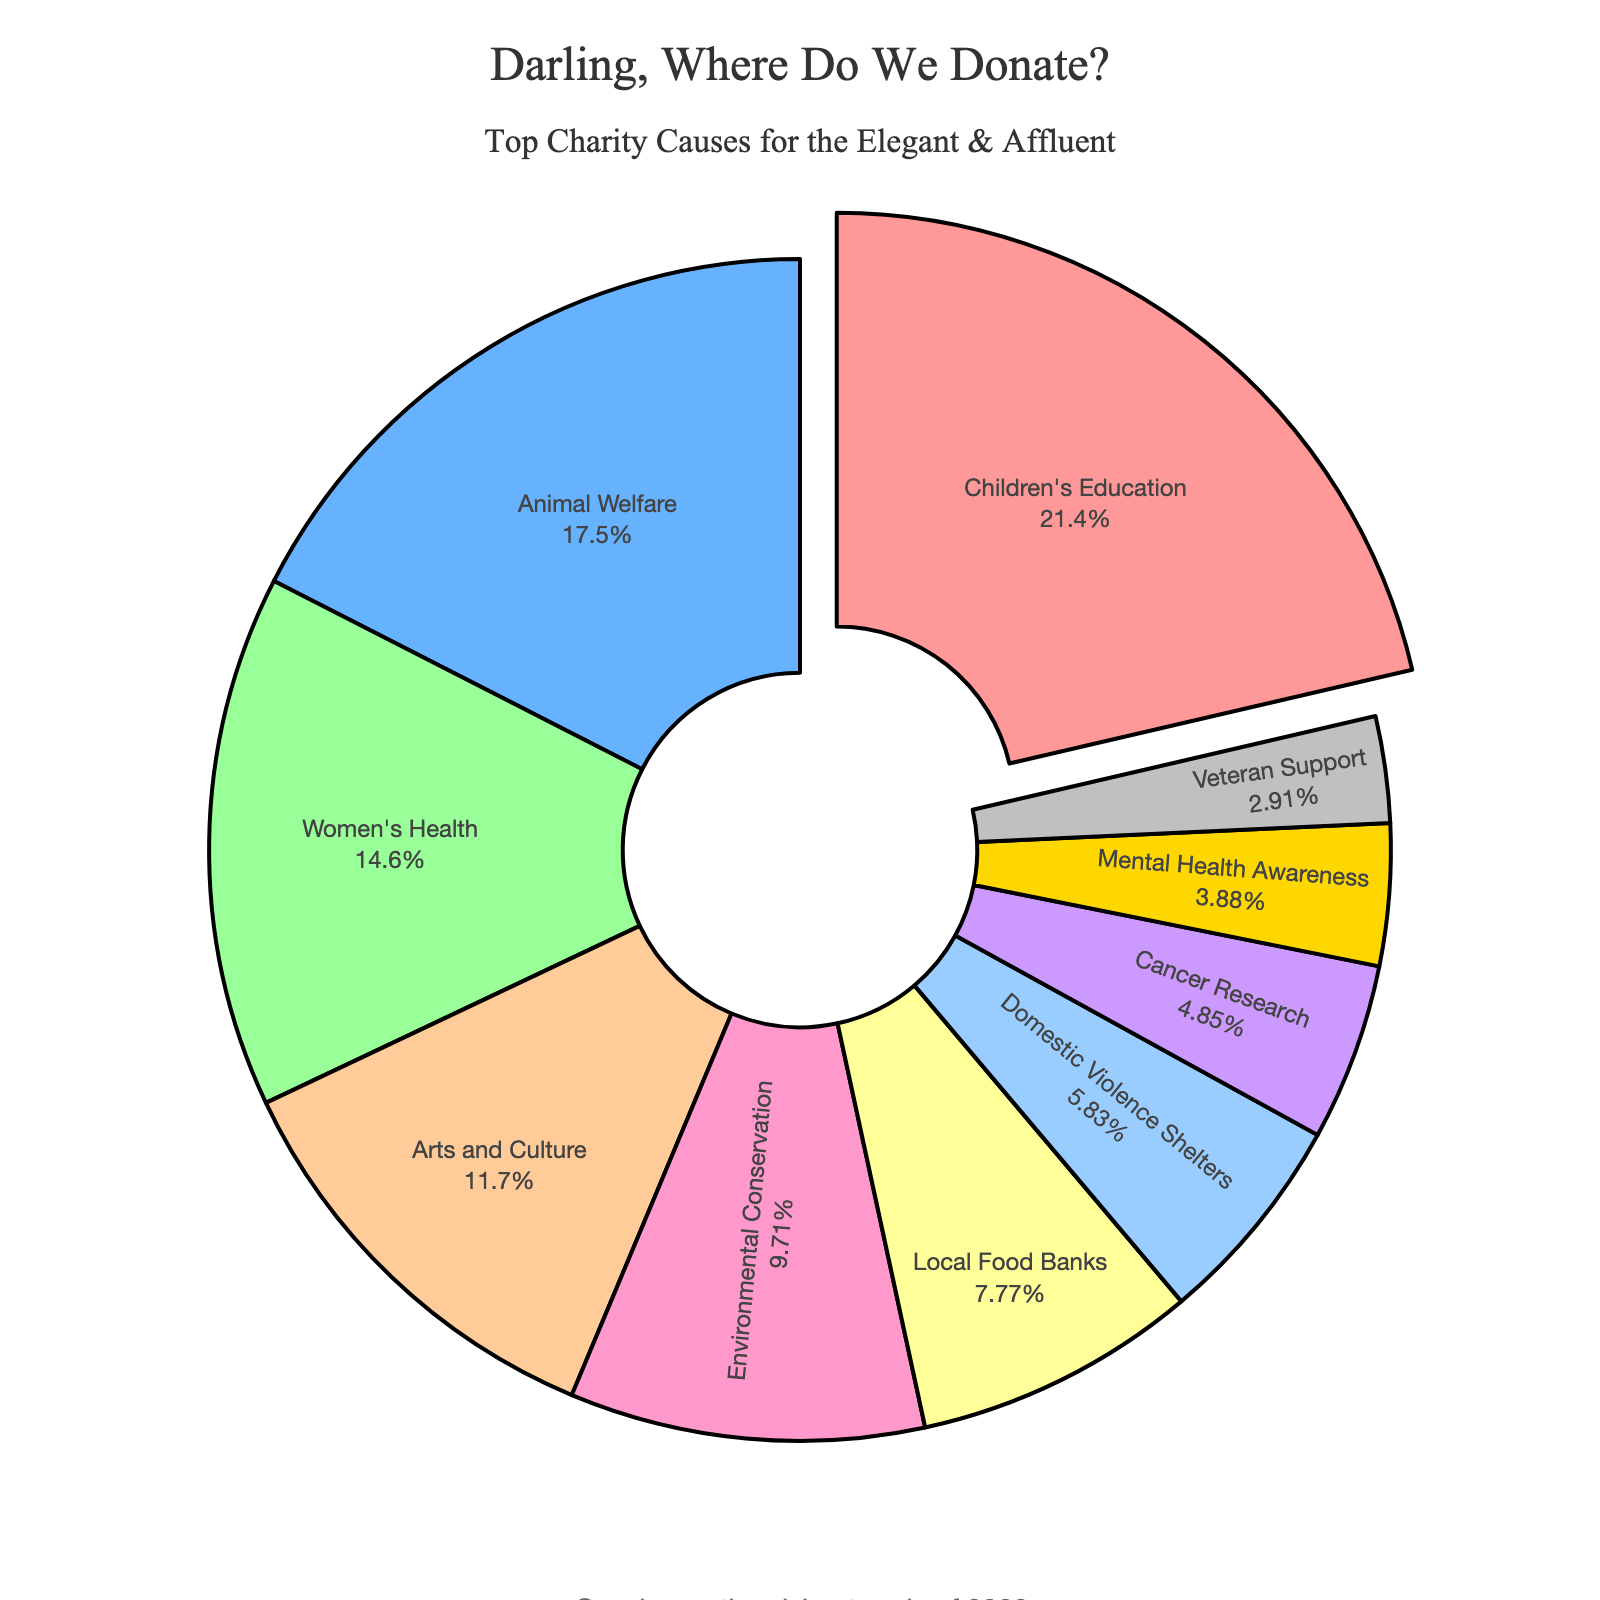Which cause has the highest percentage of support? The cause with the highest percentage is Children's Education. It stands out as the largest segment in the pie chart and is slightly pulled out to highlight its importance.
Answer: Children's Education What's the combined percentage of support for Animal Welfare and Environmental Conservation? Add the percentages for Animal Welfare (18%) and Environmental Conservation (10%). 18 + 10 = 28
Answer: 28 Is the percentage of support for Women's Health greater than that for Domestic Violence Shelters? Compare the percentages of Women's Health (15%) and Domestic Violence Shelters (6%). 15 is greater than 6.
Answer: Yes Which cause has the smallest percentage of support? Look for the smallest segment in the pie chart. The smallest value is 3%, which corresponds to Veteran Support.
Answer: Veteran Support Between Arts and Culture, and Local Food Banks, which has a higher percentage of support? Compare the percentages for Arts and Culture (12%) and Local Food Banks (8%). 12 is greater than 8.
Answer: Arts and Culture What is the total percentage of support for causes related to health (Women's Health, Cancer Research, and Mental Health Awareness)? Add the percentages for Women's Health (15%), Cancer Research (5%), and Mental Health Awareness (4%). 15 + 5 + 4 = 24
Answer: 24 What is the difference in support between Children's Education and Local Food Banks? Subtract the percentage of Local Food Banks (8%) from the percentage of Children's Education (22%). 22 - 8 = 14
Answer: 14 What percentage of support is attributed to arts and culture-related causes? Locate the percentage value for Arts and Culture, which is 12%.
Answer: 12 Which causes have a percentage of support within the range of 5% to 10%? Identify the causes within the 5% to 10% range: Environmental Conservation (10%), Local Food Banks (8%), Domestic Violence Shelters (6%), and Cancer Research (5%).
Answer: Environmental Conservation, Local Food Banks, Domestic Violence Shelters, Cancer Research Among the causes, how many have a support percentage of more than 15%? Identify the causes with percentages greater than 15%: Children's Education (22%) and Animal Welfare (18%). There are two such causes.
Answer: 2 